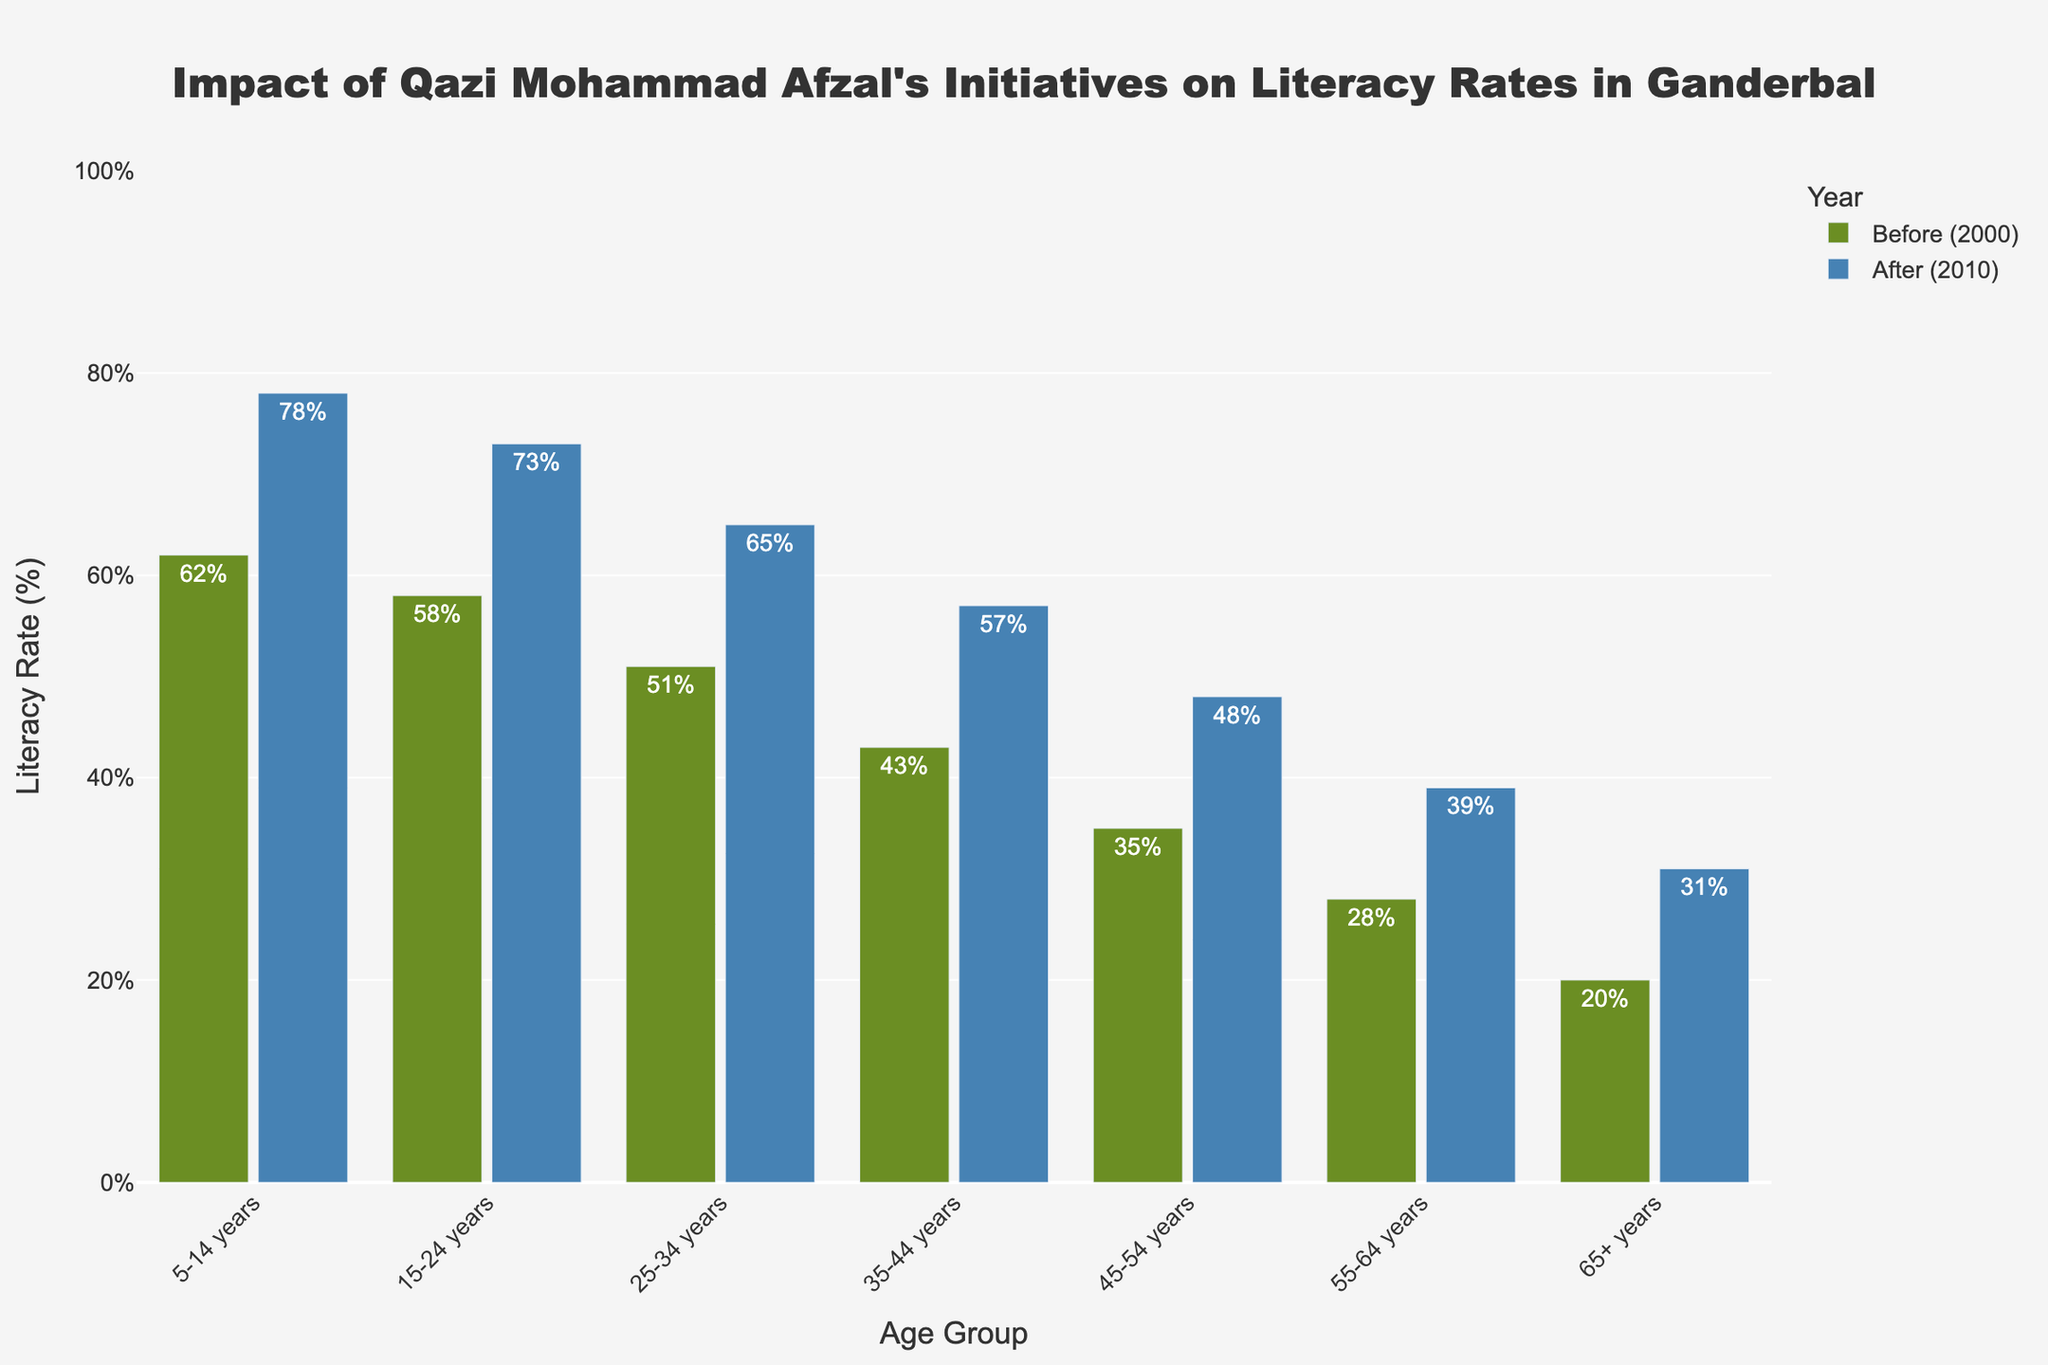What is the most significant increase in literacy rate among the age groups? The graph compares the literacy rates before (2000) and after (2010). The age group with the highest increase in literacy rate is the one with the greatest difference between the two bars representing the literacy rates. The 5-14 years age group shows an increase from 62% to 78%, which is a 16% increase, the highest among all groups.
Answer: 5-14 years Compare the literacy rates of the 35-44 years age group to the 45-54 years age group before Qazi Mohammad Afzal's initiatives. From the chart, we can see the literacy rate for the 35-44 years age group is 43%, while for the 45-54 years age group, it is 35%. By comparing these values, we find that the 35-44 years age group has a higher literacy rate by 8%.
Answer: 35-44 years (43%) is higher by 8% Which age group has the smallest increase in literacy rate from 2000 to 2010? The rate increase can be determined by subtracting the 'Literacy Rate Before (2000)' from the 'Literacy Rate After (2010)' for each age group. By comparing these differences, we observe that the age group 65+ has the smallest increase from 20% to 31%, a difference of 11%.
Answer: 65+ years How does the literacy rate improve for the 25-34 years age group after Qazi Mohammad Afzal's initiatives? The literacy rate for the 25-34 years age group improves from 51% in 2000 to 65% in 2010. The improvement can be determined by subtracting the two values: 65% - 51%, resulting in a 14% increase.
Answer: 14% Which age group had the lowest literacy rate before the initiatives and what was it? By examining the height of the bars representing 'Literacy Rate Before (2000)', the age group 65+ years had the lowest literacy rate before the initiatives, which was 20%.
Answer: 65+ years, 20% Identify the age group that shows the most significant visual improvement after Qazi Mohammad Afzal's initiatives. Visually, we observe the relative heights of the bars. The 5-14 years age group's bar for 2010 (blue) is significantly higher compared to its 2000 bar (green), indicating the most apparent visual improvement.
Answer: 5-14 years What is the average literacy rate improvement across all age groups? To determine the average improvement, we calculate the differences for each group: 16% (5-14), 15% (15-24), 14% (25-34), 14% (35-44), 13% (45-54), 11% (55-64), 11% (65+). Adding these values gives 94%, and dividing by the number of groups (7) gives an average improvement of 13.43%.
Answer: 13.43% Examine the literacy rates of the age groups 45-54 years and 55-64 years after the initiatives. Which group has a higher rate and by how much? For 2010, the literacy rate for the 45-54 years age group is 48%, while for the 55-64 years age group, it is 39%. The 45-54 years group has a higher rate by 9%.
Answer: 45-54 years by 9% 